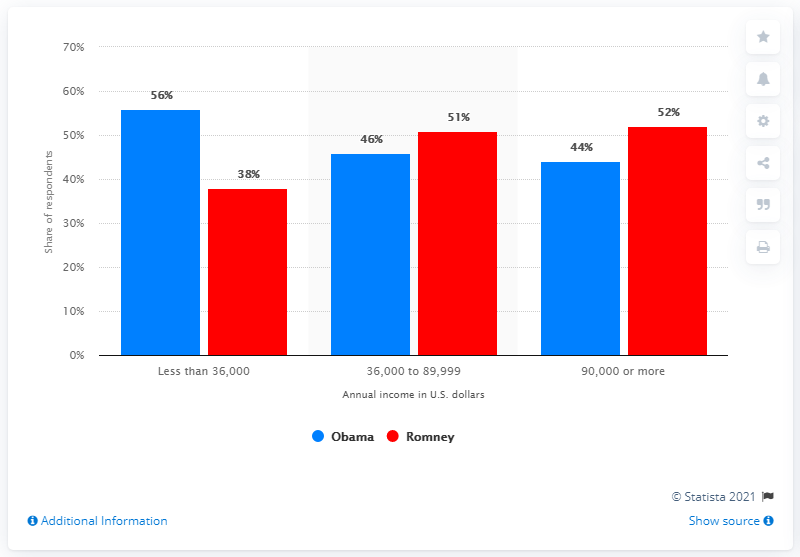Indicate a few pertinent items in this graphic. The difference between the highest annual income between President Barack Obama and former Governor Mitt Romney in 2012 was approximately 4 million dollars. The difference between the shortest light blue bar and the tallest red bar is -8. 